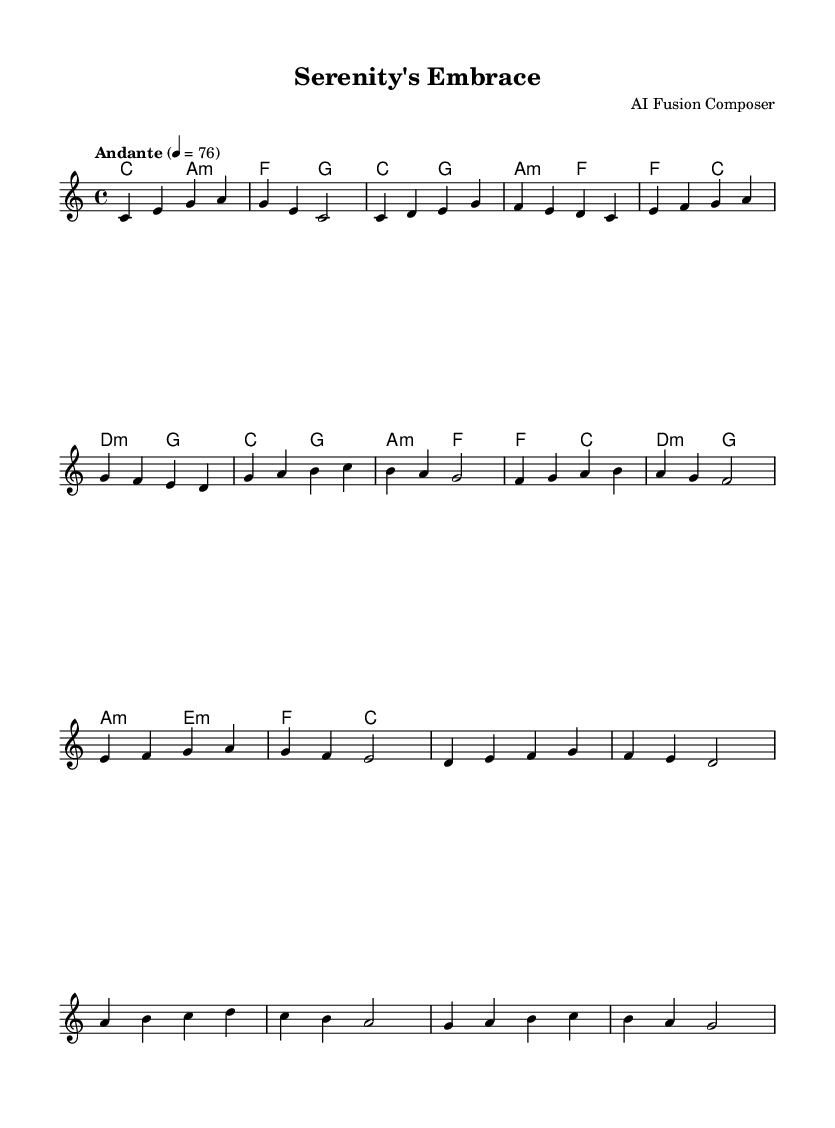What is the key signature of this music? The key signature is C major, which has no sharps or flats indicated in the sheet music.
Answer: C major What is the time signature of this piece? The time signature is indicated as 4/4, which is a common time signature where each measure contains four beats.
Answer: 4/4 What is the tempo marking for this piece? The tempo marking is "Andante", which suggests a moderate pace, typically around 76 beats per minute, as indicated in the sheet music.
Answer: Andante How many measures are in the verse? The verse consists of 8 measures indicated in the sheet music. Counting the measures labeled in the melody section confirms this.
Answer: 8 Which chords are used in the chorus? The chorus employs the chords C, G, A minor, and F, as seen in the chord progression written in the harmonies section for the chorus.
Answer: C, G, A minor, F What is the primary genre fusion of this piece? The primary genre fusion is between classical and pop elements, evident in the melodic structure and harmonic progression, which blends classical style with contemporary sound.
Answer: Classical-pop What is the main theme or feel projected by the melody? The main theme is serene and soothing, indicated by the flow and the type of notes used in the melody, creating a calming effect typical in relaxation music.
Answer: Serene 